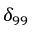<formula> <loc_0><loc_0><loc_500><loc_500>\delta _ { 9 9 }</formula> 